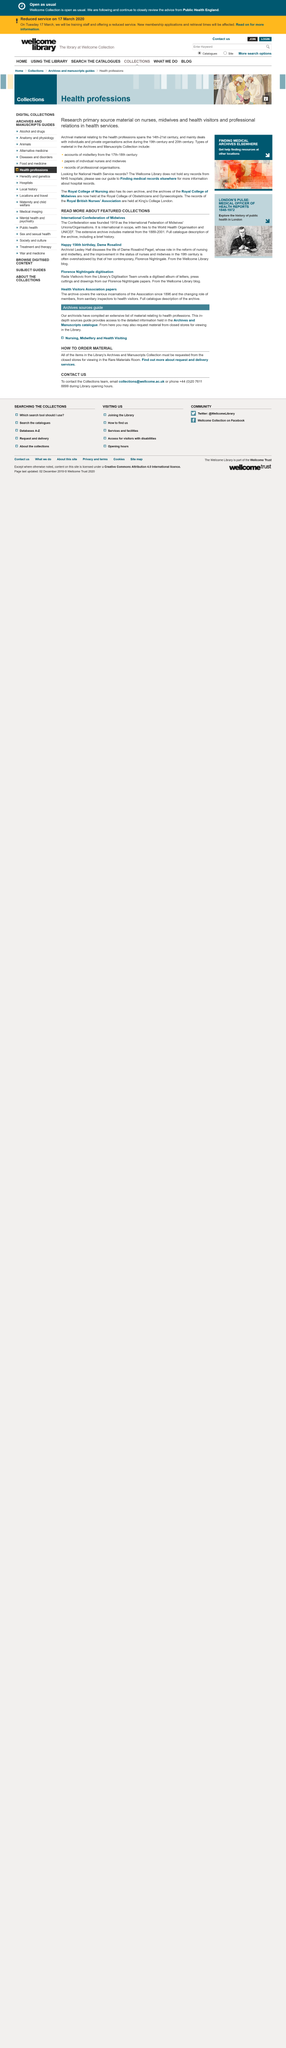Point out several critical features in this image. The International Confederation of Midwives was founded in 1919. Lesley Hall is the archivist who discusses the life of Dame Rosalind Paget in the video. Dame Rosalind celebrated her 156th birthday in this featured collection. 